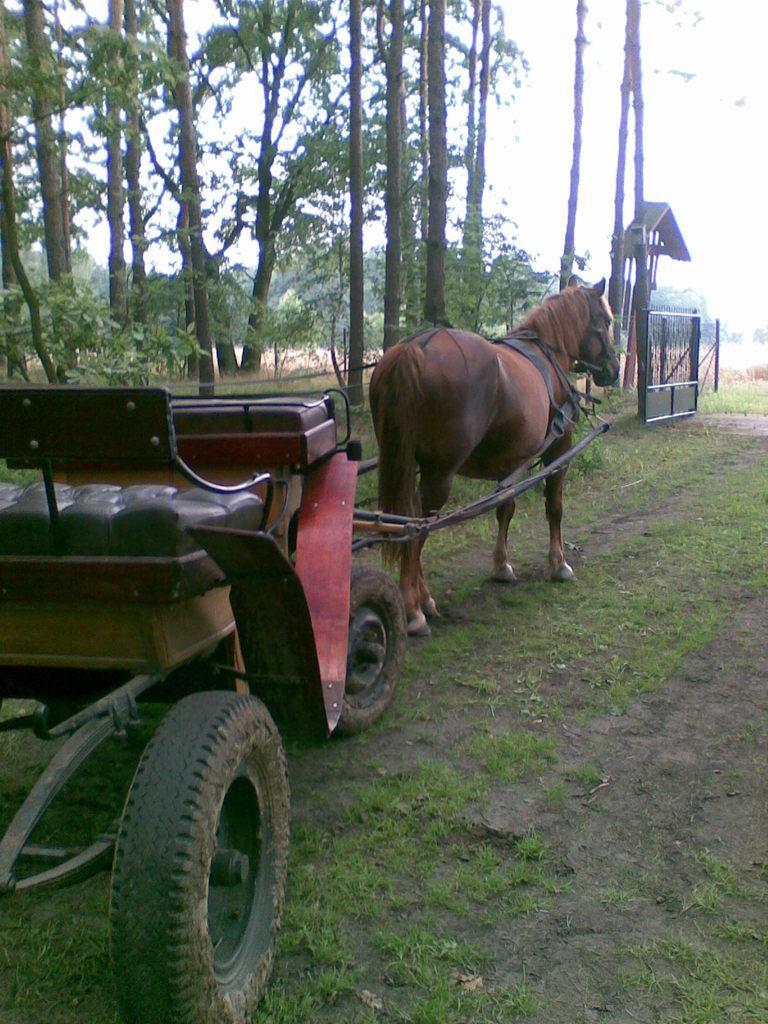Please provide a concise description of this image. In this picture we can see a horse drawn cart moving on the grass, around we can see a gate and some trees. 